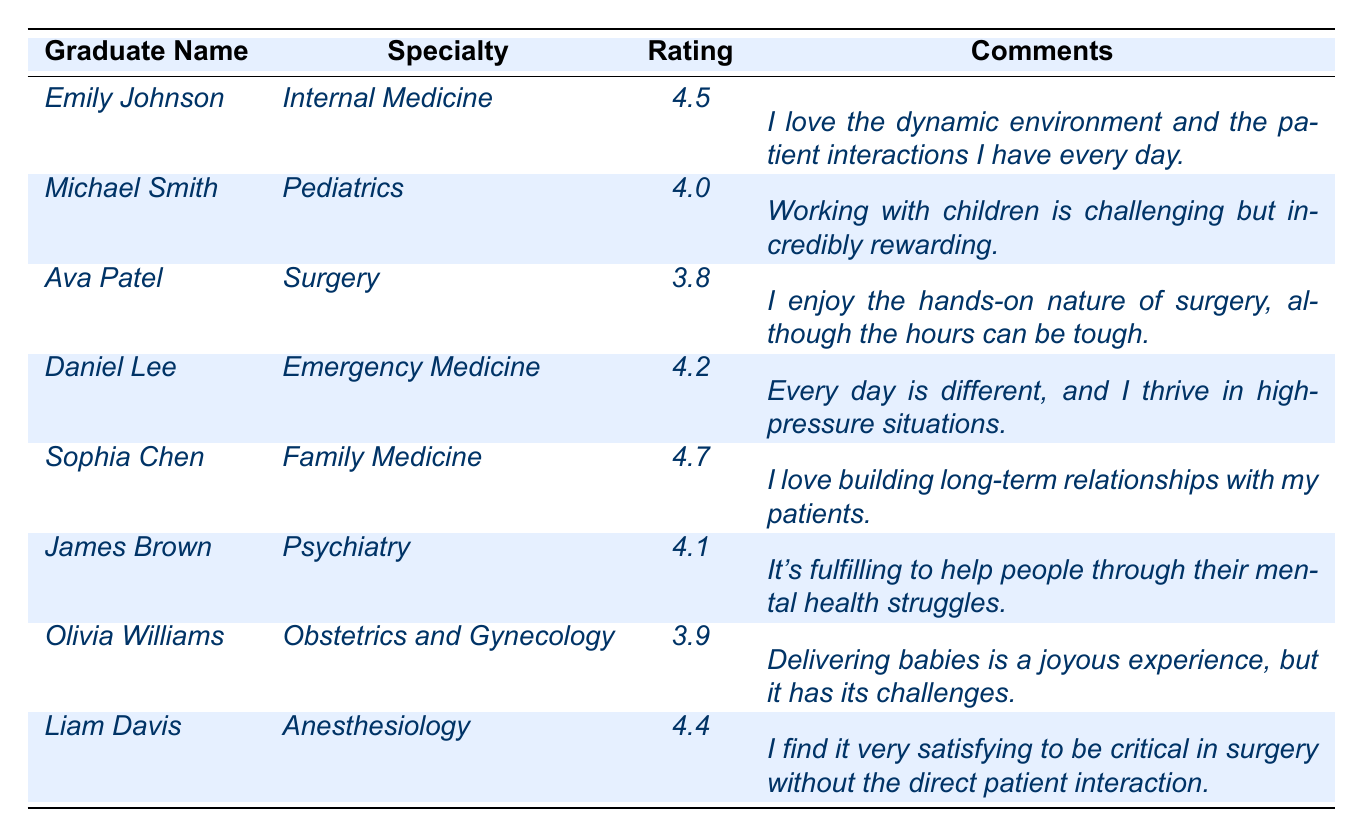What is the highest job satisfaction rating in the table? The highest rating can be found by comparing the job satisfaction ratings listed for each graduate. Upon reviewing the data, Sophia Chen has the highest rating of 4.7.
Answer: 4.7 Which specialty has the lowest job satisfaction rating? To find the lowest rating, we look at each rating in the table. Ava Patel, in Surgery, has the lowest rating of 3.8.
Answer: Surgery How many graduates have a job satisfaction rating of 4.0 or higher? We can count the number of ratings that are 4.0 or above. The ratings are 4.5, 4.0, 4.2, 4.7, 4.1, and 4.4, totaling six graduates.
Answer: 6 What is the average job satisfaction rating of all graduates? To find the average, we sum all the ratings: (4.5 + 4.0 + 3.8 + 4.2 + 4.7 + 4.1 + 3.9 + 4.4) = 34.6. There are 8 graduates, so the average is 34.6 / 8 = 4.325.
Answer: 4.325 Did any graduate comment that their work is challenging? We can search through the comments provided. Both Ava Patel ("the hours can be tough") and Michael Smith ("Working with children is... challenging") indicated challenges in their work.
Answer: Yes Are there more graduates with a job satisfaction rating above 4.0 or below 4.0? We look at all the ratings: ratings above 4.0 are 4.5, 4.0, 4.2, 4.7, 4.1, and 4.4 (6 total). Ratings below 4.0 are 3.8 and 3.9 (2 total). There are more graduates above 4.0.
Answer: Above 4.0 What percentage of graduates are in specialties that have a rating of 4.0 or higher? First, we count the specialties with ratings of 4.0 or higher: there are 6 such graduates out of 8 total graduates. The percentage is (6/8) * 100 = 75%.
Answer: 75% Which graduate has the highest job satisfaction rating among emergency medicine specialists? From the table, Daniel Lee is the only graduate listed under Emergency Medicine with a rating of 4.2, making him the highest in that specialty.
Answer: Daniel Lee Compare the comments of the highest and lowest-rated graduates. What is the main difference in sentiment? Sophia Chen, who has the highest rating, expresses love for building long-term patient relationships, while Ava Patel, the lowest-rated graduate, mentions the tough hours in surgery indicating some dissatisfaction. The main difference shows contentment vs. concern about work-life balance.
Answer: Contentment vs. concern Which specialty has a job satisfaction rating closest to the average rating? The average rating is 4.325. The closest ratings are 4.4 (Anesthesiology) and 4.2 (Emergency Medicine). Anesthesiology is the closest to the average.
Answer: Anesthesiology 